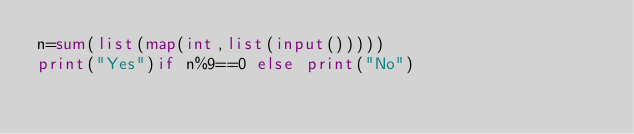<code> <loc_0><loc_0><loc_500><loc_500><_Python_>n=sum(list(map(int,list(input()))))
print("Yes")if n%9==0 else print("No")</code> 